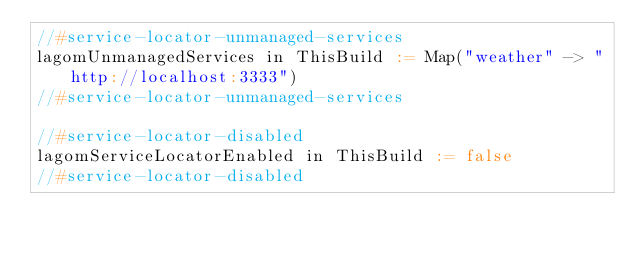<code> <loc_0><loc_0><loc_500><loc_500><_Scala_>//#service-locator-unmanaged-services
lagomUnmanagedServices in ThisBuild := Map("weather" -> "http://localhost:3333")
//#service-locator-unmanaged-services

//#service-locator-disabled
lagomServiceLocatorEnabled in ThisBuild := false
//#service-locator-disabled
</code> 